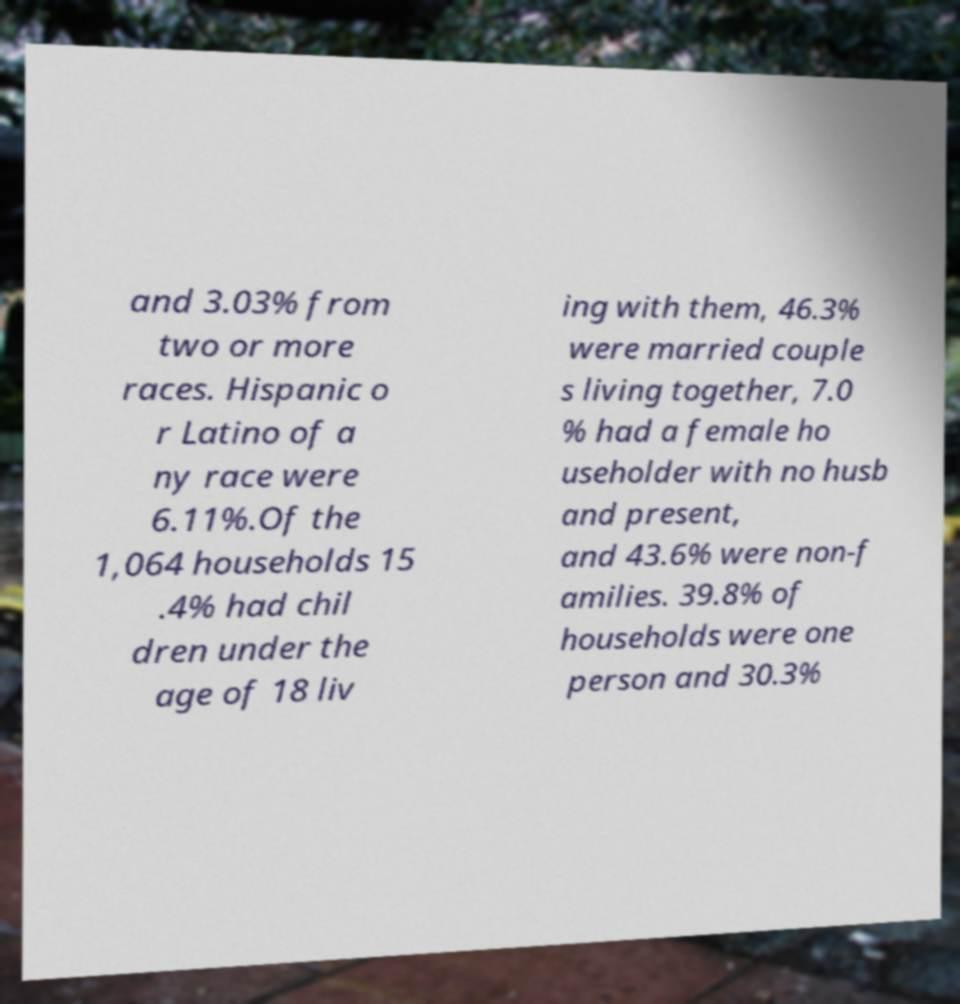I need the written content from this picture converted into text. Can you do that? and 3.03% from two or more races. Hispanic o r Latino of a ny race were 6.11%.Of the 1,064 households 15 .4% had chil dren under the age of 18 liv ing with them, 46.3% were married couple s living together, 7.0 % had a female ho useholder with no husb and present, and 43.6% were non-f amilies. 39.8% of households were one person and 30.3% 